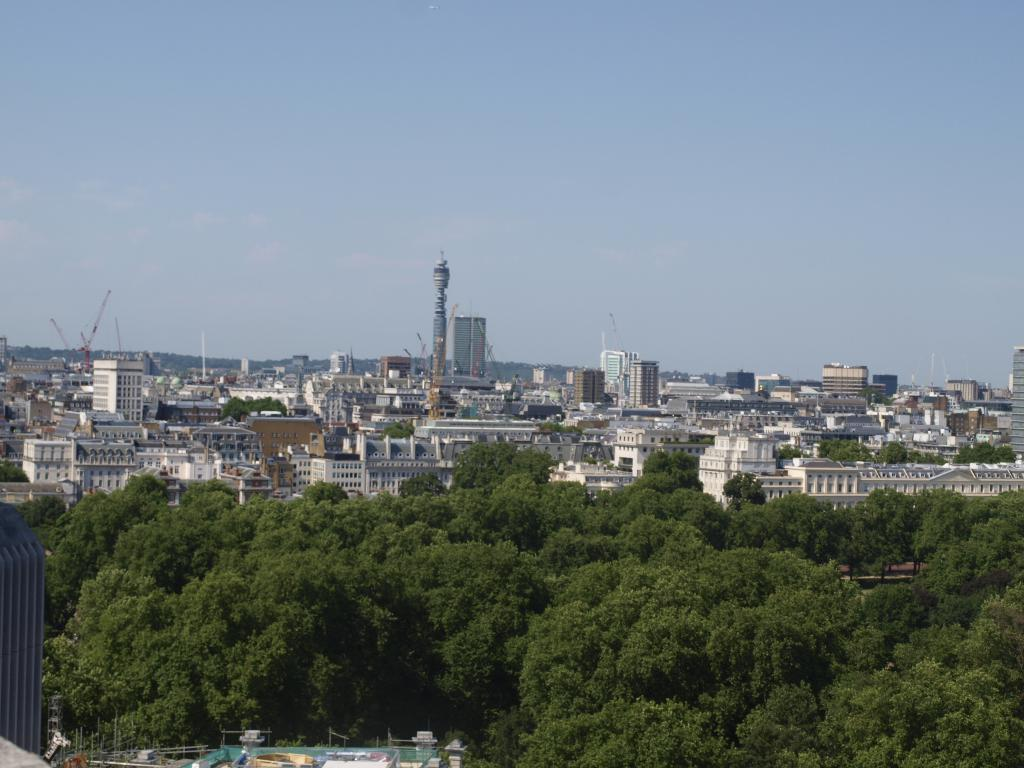What types of structures can be seen at the bottom of the image? There are trees, buildings, and houses at the bottom of the image. What types of structures can be seen in the background of the image? There are towers, buildings, houses, and trees in the background of the image. What else can be seen in the background of the image? There are poles in the background of the image. What is visible at the top of the image? The sky is visible at the top of the image. What day of the week is depicted in the image? The image does not depict a specific day of the week. Can you identify the fire hydrant in the image? There is no fire hydrant present in the image. Who is the representative in the image? The image does not depict a specific person or representative. 